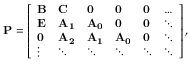<formula> <loc_0><loc_0><loc_500><loc_500>P = \left [ \begin{array} { l l l l l l } { B } & { C } & { 0 } & { 0 } & { 0 } & { \dots } \\ { E } & { A _ { 1 } } & { A _ { 0 } } & { 0 } & { 0 } & { \ddots } \\ { 0 } & { A _ { 2 } } & { A _ { 1 } } & { A _ { 0 } } & { 0 } & { \ddots } \\ { \vdots } & { \ddots } & { \ddots } & { \ddots } & { \ddots } & { \ddots } \end{array} \right ] ,</formula> 